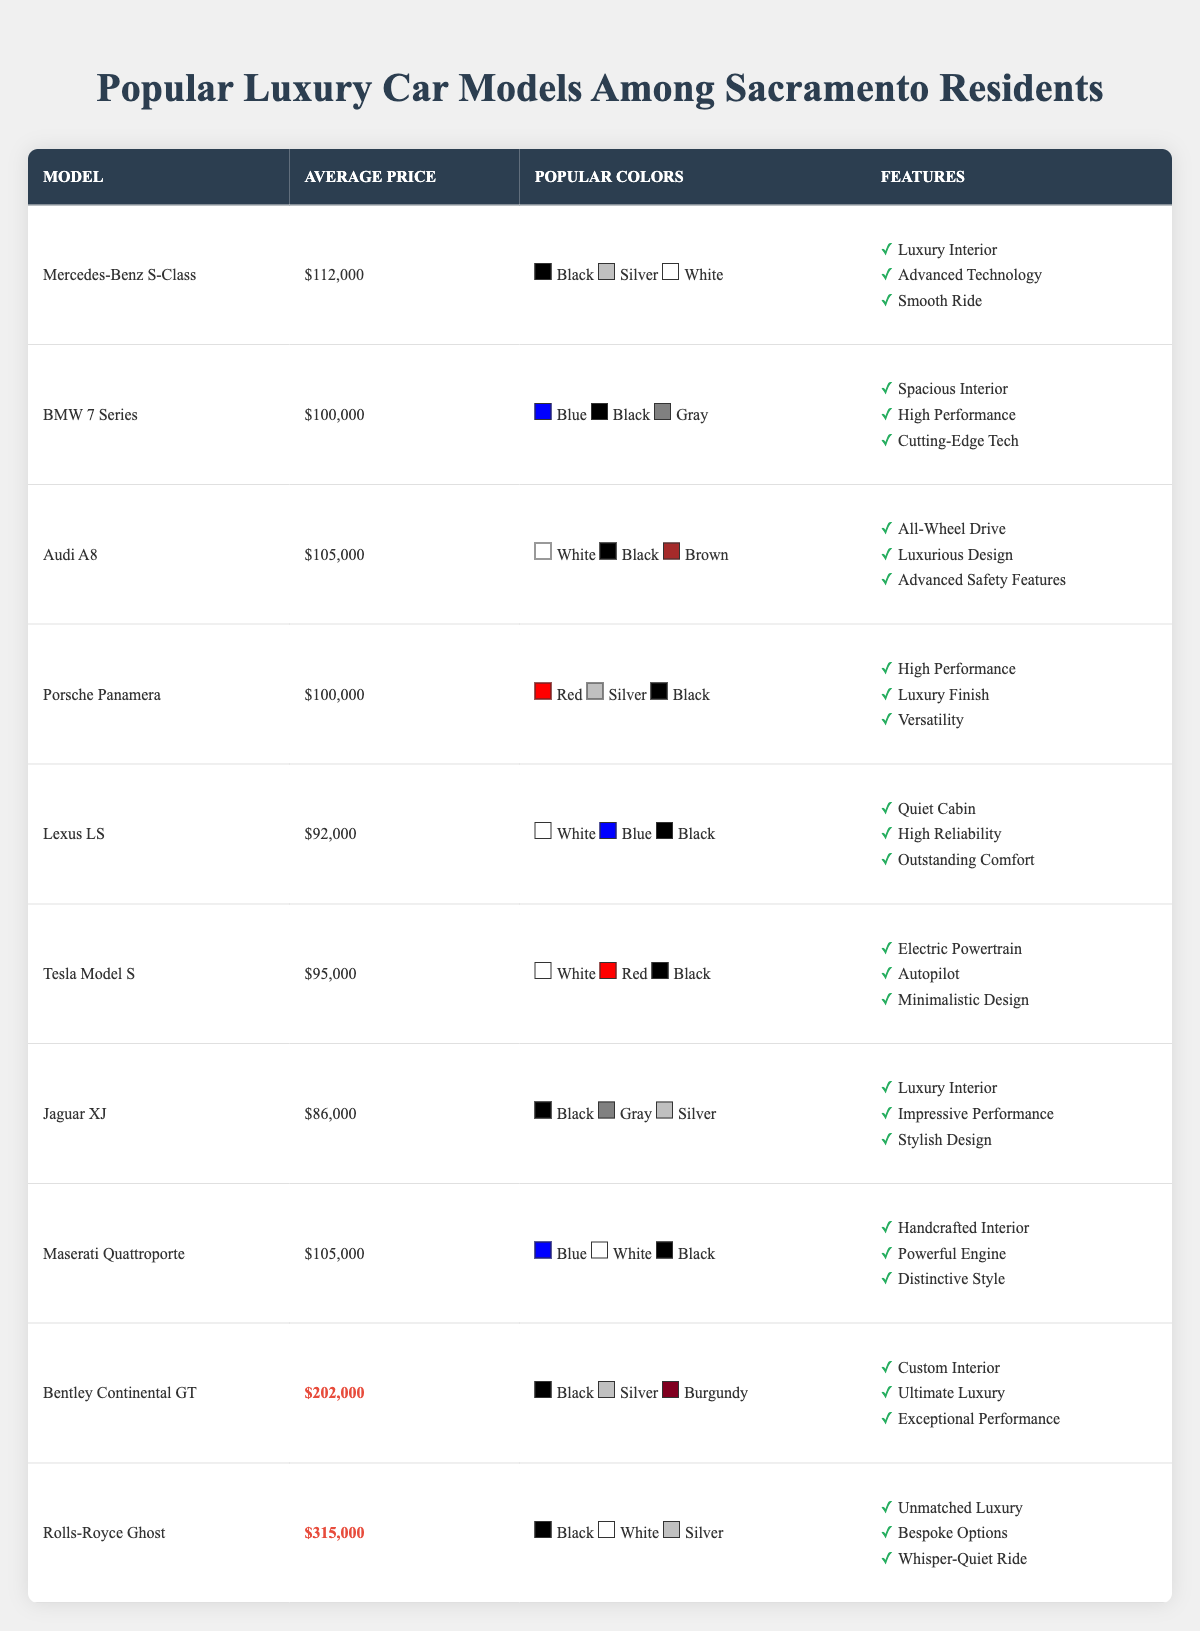What is the average price of the Rolls-Royce Ghost? The average price of the Rolls-Royce Ghost is listed in the table as $315,000.
Answer: $315,000 Which car model has the highest average price? The table shows that the Rolls-Royce Ghost has the highest average price of $315,000, compared to all other models.
Answer: Rolls-Royce Ghost How many cars have an average price of $100,000? The models under this price are BMW 7 Series and Porsche Panamera, both at $100,000, giving a total count of 2 models.
Answer: 2 What is the total average price of the Bentley Continental GT and Rolls-Royce Ghost? The average price of the Bentley Continental GT is $202,000 and the Rolls-Royce Ghost is $315,000. Adding these together ($202,000 + $315,000) equals $517,000.
Answer: $517,000 Is the Jaguar XJ more expensive than the Tesla Model S? The average price of the Jaguar XJ is $86,000, while the Tesla Model S is $95,000, thus it is not more expensive.
Answer: No Which car has a color option that includes "Burgundy"? The Bentley Continental GT has a color option that includes Burgundy according to the popular colors listed in the table.
Answer: Bentley Continental GT How many different colors are popular for the Lexus LS? The table lists three popular colors for the Lexus LS: White, Blue, and Black, hence the answer is three.
Answer: 3 Are there any two cars with the same average price, and if so, what are they? Yes, both the BMW 7 Series and Porsche Panamera have the same average price of $100,000.
Answer: Yes, BMW 7 Series and Porsche Panamera What is the average price of the cars that have "Luxury Interior" as a feature? The models with "Luxury Interior" are Mercedes-Benz S-Class, Jaguar XJ, and Maserati Quattroporte, with average prices of $112,000, $86,000, and $105,000 respectively. Their total is $303,000 and the average is $303,000/3 = $101,000.
Answer: $101,000 Which luxury car has features including "Electric Powertrain" and what is its average price? The Tesla Model S has "Electric Powertrain" as one of its features, and its average price is listed as $95,000.
Answer: Tesla Model S, $95,000 